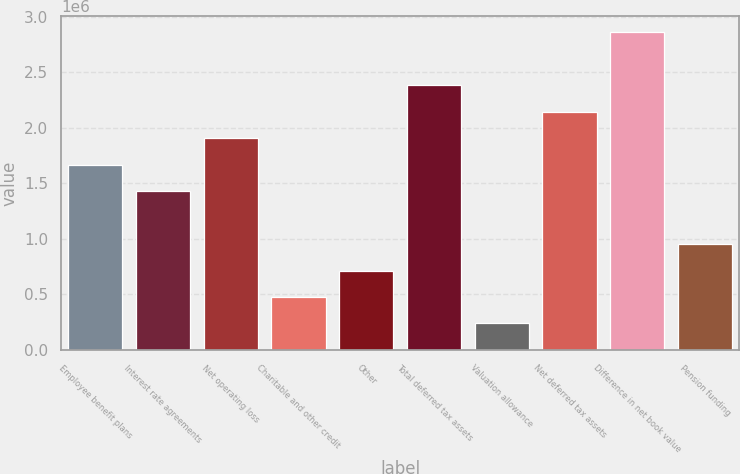<chart> <loc_0><loc_0><loc_500><loc_500><bar_chart><fcel>Employee benefit plans<fcel>Interest rate agreements<fcel>Net operating loss<fcel>Charitable and other credit<fcel>Other<fcel>Total deferred tax assets<fcel>Valuation allowance<fcel>Net deferred tax assets<fcel>Difference in net book value<fcel>Pension funding<nl><fcel>1.6686e+06<fcel>1.43036e+06<fcel>1.90685e+06<fcel>477359<fcel>715608<fcel>2.38335e+06<fcel>239110<fcel>2.1451e+06<fcel>2.85985e+06<fcel>953857<nl></chart> 